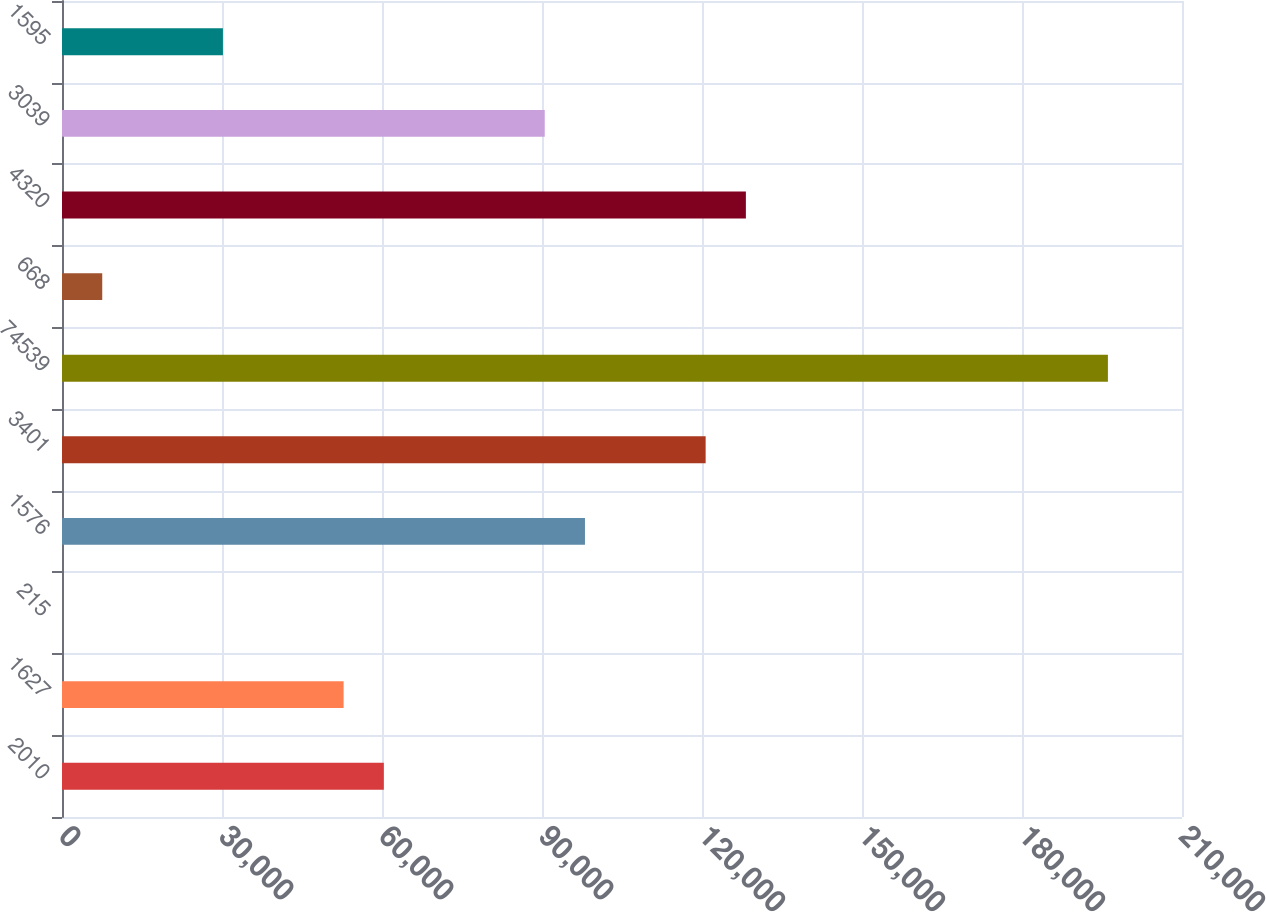Convert chart. <chart><loc_0><loc_0><loc_500><loc_500><bar_chart><fcel>2010<fcel>1627<fcel>215<fcel>1576<fcel>3401<fcel>74539<fcel>668<fcel>4320<fcel>3039<fcel>1595<nl><fcel>60342.9<fcel>52800.4<fcel>2.51<fcel>98055.7<fcel>120683<fcel>196109<fcel>7545.06<fcel>128226<fcel>90513.1<fcel>30172.7<nl></chart> 